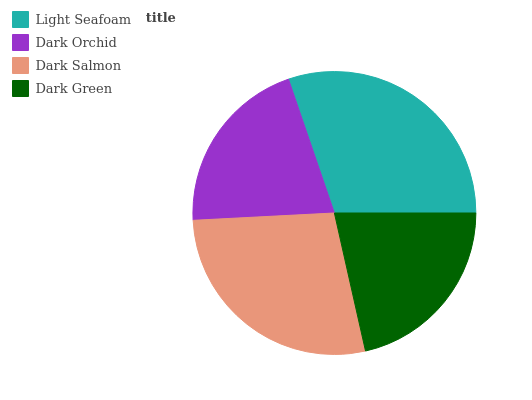Is Dark Orchid the minimum?
Answer yes or no. Yes. Is Light Seafoam the maximum?
Answer yes or no. Yes. Is Dark Salmon the minimum?
Answer yes or no. No. Is Dark Salmon the maximum?
Answer yes or no. No. Is Dark Salmon greater than Dark Orchid?
Answer yes or no. Yes. Is Dark Orchid less than Dark Salmon?
Answer yes or no. Yes. Is Dark Orchid greater than Dark Salmon?
Answer yes or no. No. Is Dark Salmon less than Dark Orchid?
Answer yes or no. No. Is Dark Salmon the high median?
Answer yes or no. Yes. Is Dark Green the low median?
Answer yes or no. Yes. Is Dark Orchid the high median?
Answer yes or no. No. Is Dark Orchid the low median?
Answer yes or no. No. 